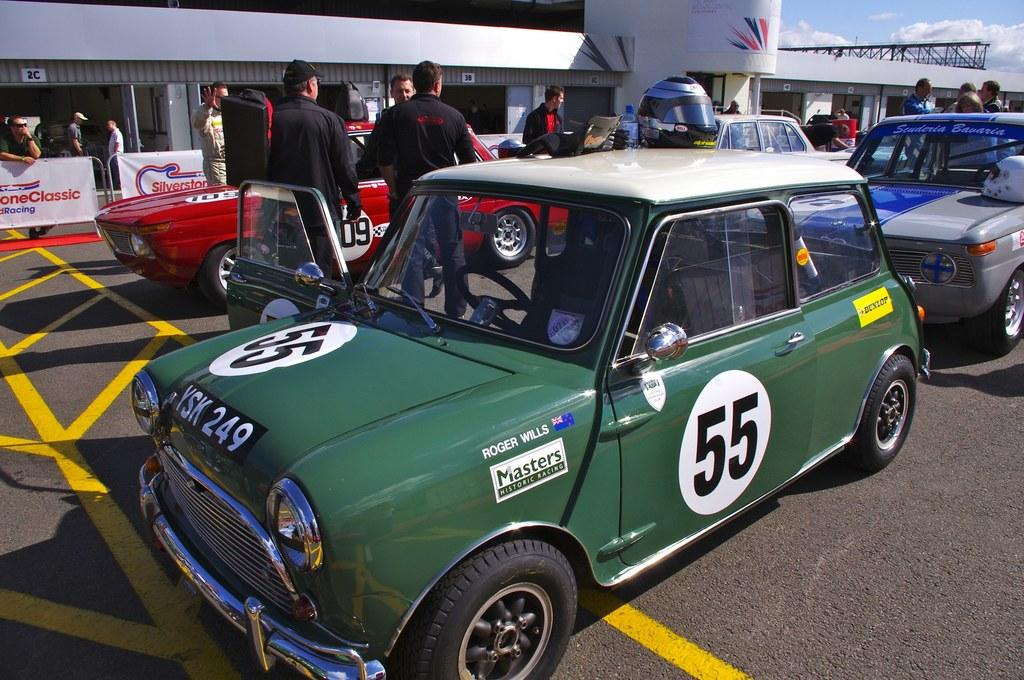What can be seen on the road in the image? There are cars parked on the road in the image. What are the people near the cars doing? There are people standing beside the cars in the image. What is visible in the background of the image? There is a building visible in the background of the image. What safety equipment is present in the image? A helmet is kept on one of the cars in the image. What type of chalk is being used by the grandfather in the image? There is no grandfather or chalk present in the image. What answer is being given by the person in the image? There is no person giving an answer in the image; it only shows parked cars, people standing beside them, a building in the background, and a helmet on one of the cars. 